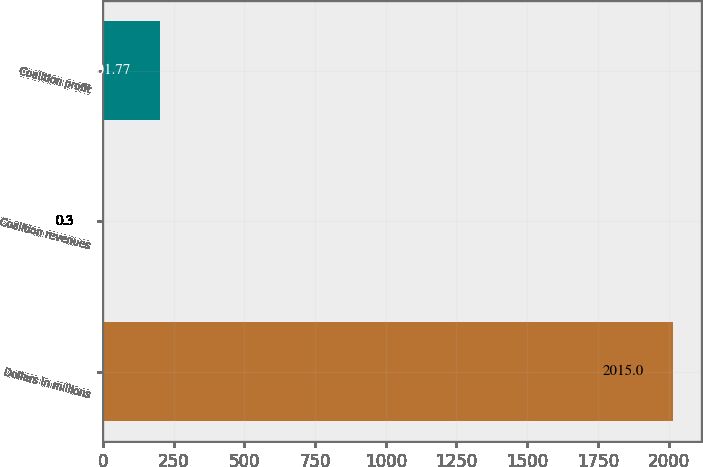Convert chart. <chart><loc_0><loc_0><loc_500><loc_500><bar_chart><fcel>Dollars in millions<fcel>Coalition revenues<fcel>Coalition profit<nl><fcel>2015<fcel>0.3<fcel>201.77<nl></chart> 